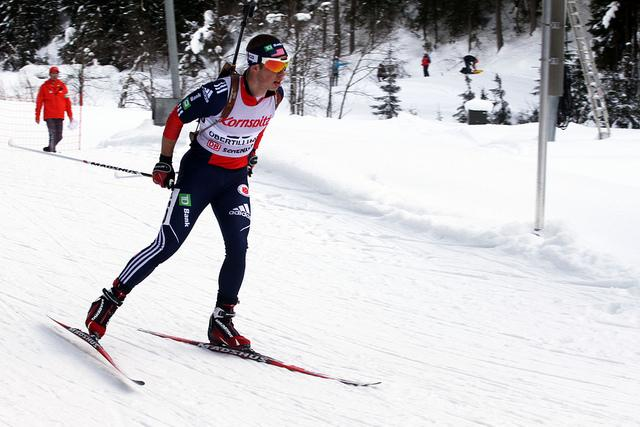What is required for this activity?

Choices:
A) sun
B) snow
C) wind
D) water snow 